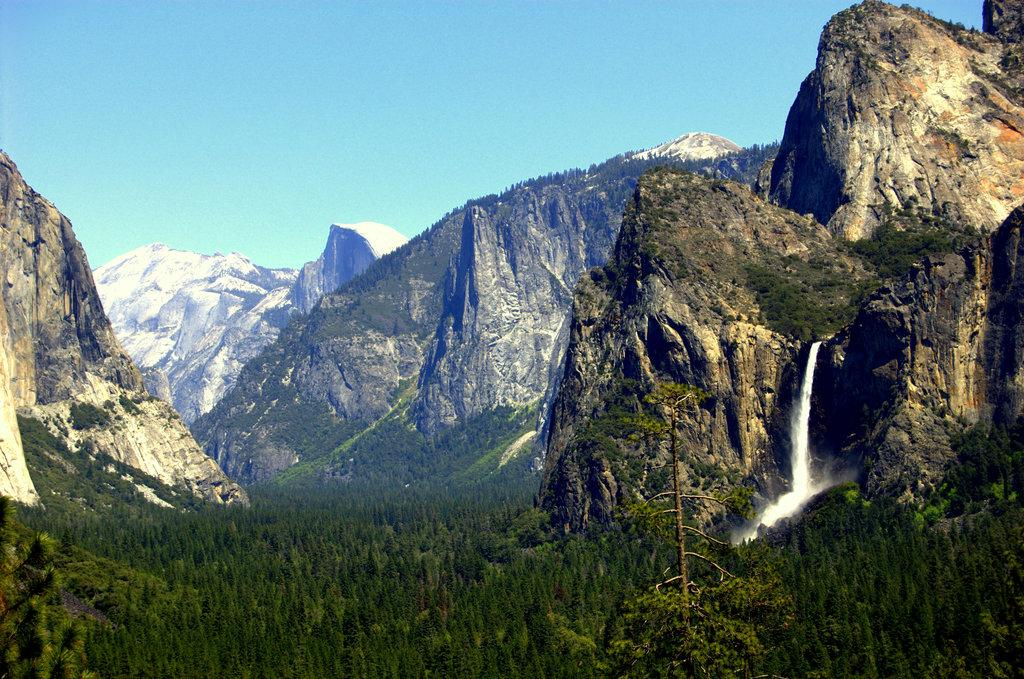What type of landscape can be seen in the image? There are hills in the image. What is happening with the water in the image? Water is flowing in the image. What type of vegetation is present in the image? There are trees in the image. What color is the sky in the image? The sky is blue in the image. Can you tell me how many guides are present in the image? There are no guides present in the image. What type of fight can be seen taking place in the image? There is no fight present in the image. 